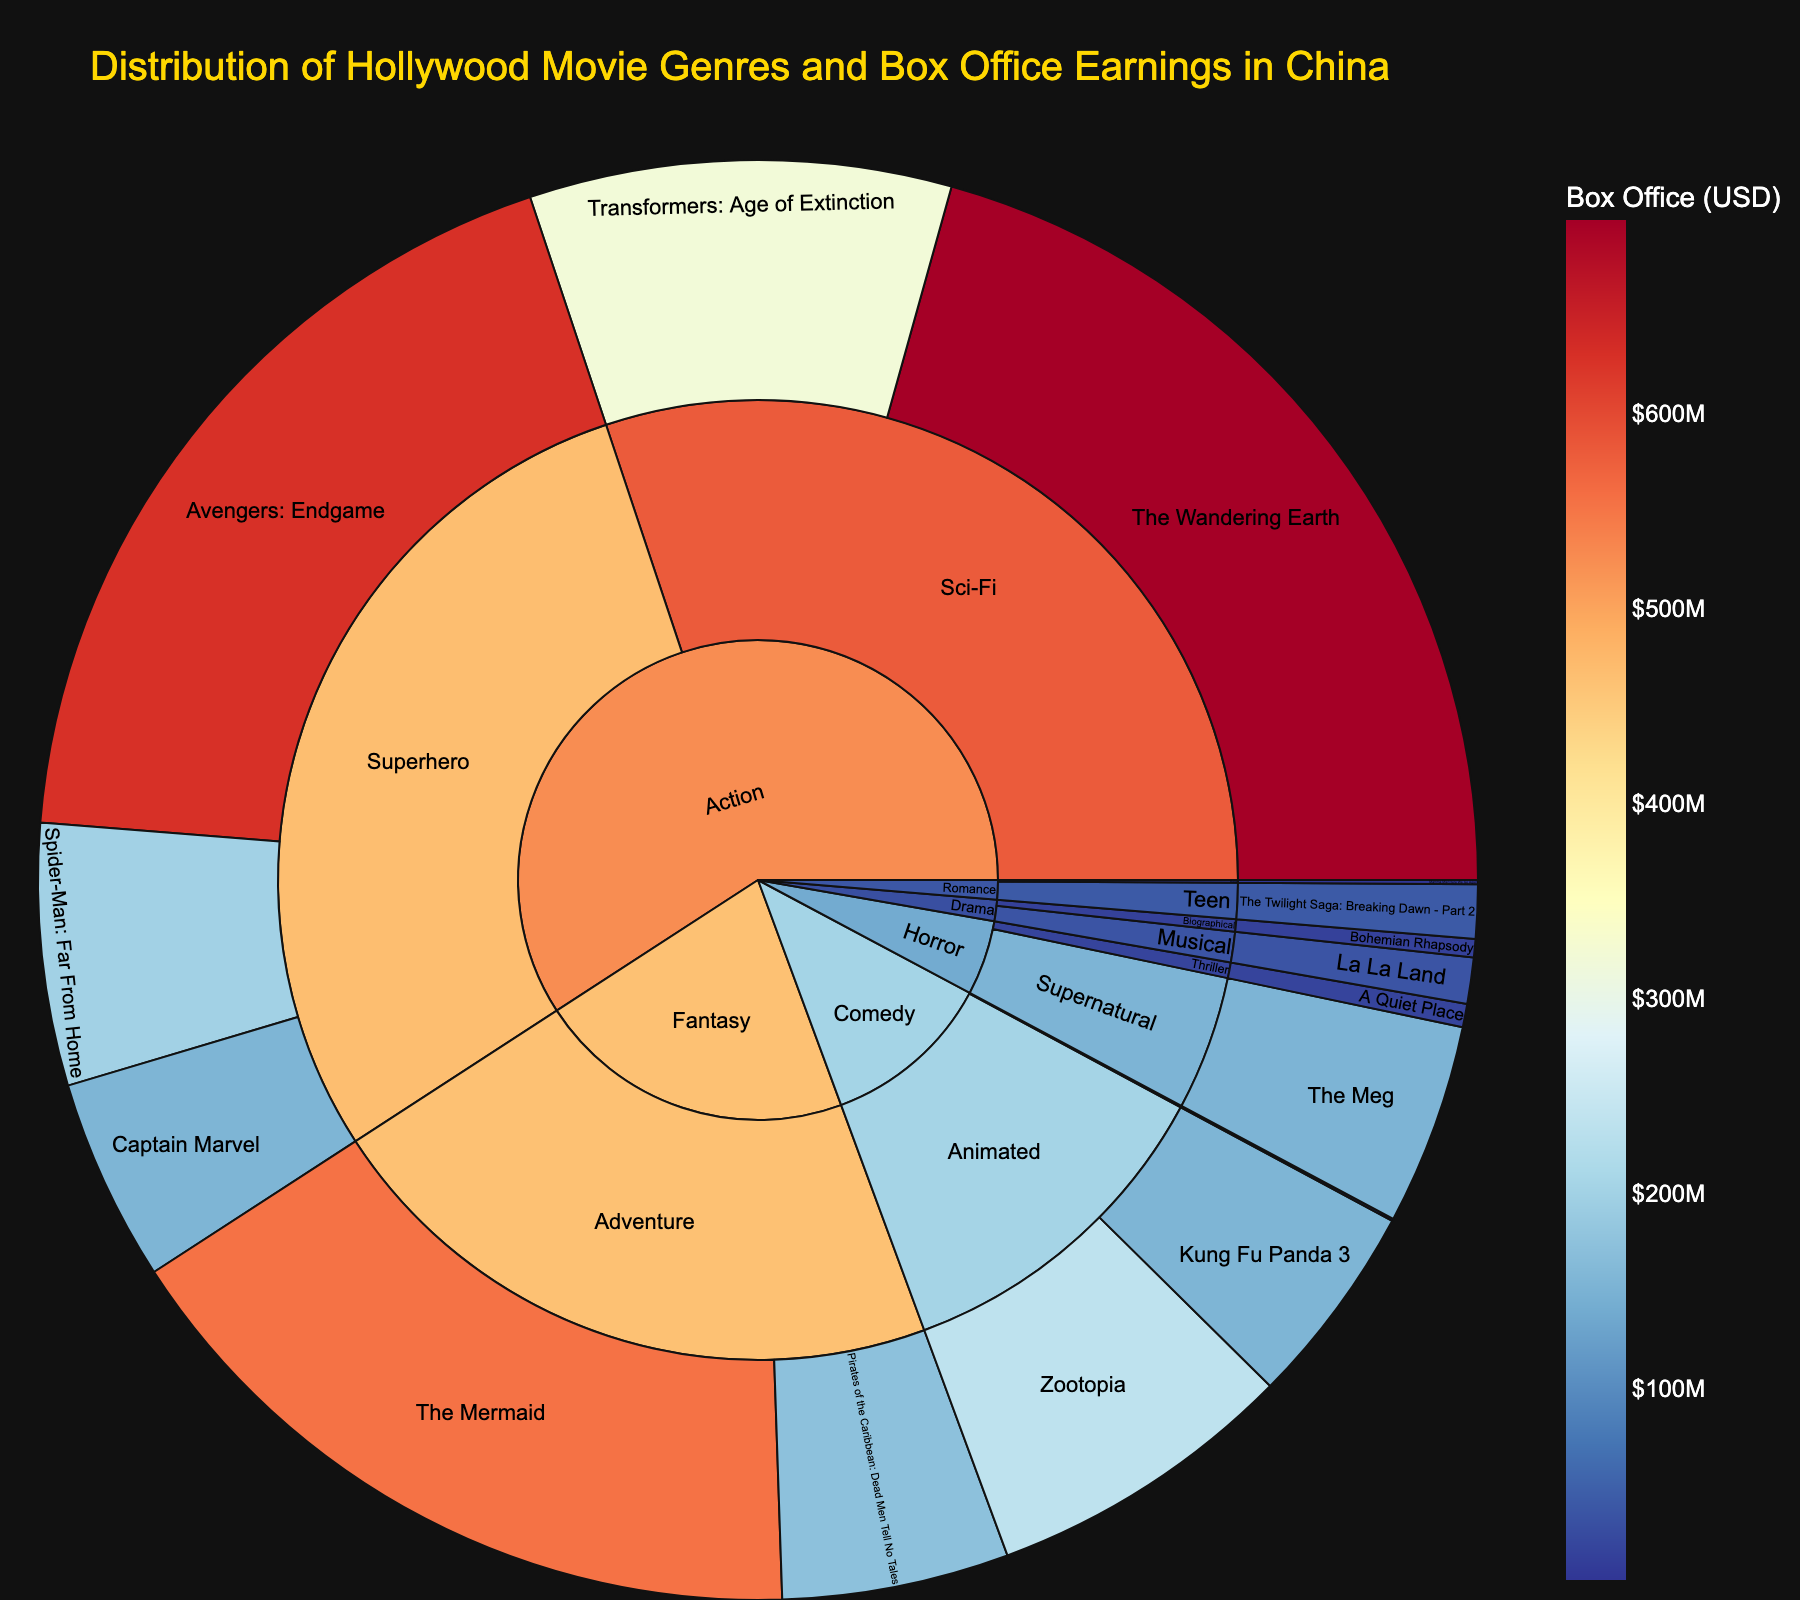What's the genre with the highest box office earnings? Look at the outer ring of the sunburst plot and sum the box office earnings for each genre. The 'Action' genre has multiple high-grossing movies like "Avengers: Endgame" and "The Wandering Earth," making it the highest.
Answer: Action Which movie has the highest box office earnings in China? Examine the smallest segments of the sunburst plot, which represent individual movies. "The Wandering Earth" stands out with the highest earnings at $699,000,000.
Answer: The Wandering Earth How does the box office earnings of "Avengers: Endgame" compare to "The Wandering Earth"? Identify the segments for both movies. "Avengers: Endgame" earned $629,000,000, while "The Wandering Earth" earned $699,000,000. Comparing these, "The Wandering Earth" earned more.
Answer: The Wandering Earth earned more What's the total box office earnings for Superhero subgenre movies? Add the box office earnings of "Avengers: Endgame" ($629,000,000), "Spider-Man: Far From Home" ($199,000,000), and "Captain Marvel" ($154,000,000). The total is $629,000,000 + $199,000,000 + $154,000,000 = $982,000,000.
Answer: $982,000,000 What are the top 3 movies by box office earnings in China? Look at the smallest segments representing individual movies and identify the top 3. "The Wandering Earth" ($699,000,000), "Avengers: Endgame" ($629,000,000), and "The Mermaid" ($553,800,000) are the top 3 movies.
Answer: The Wandering Earth, Avengers: Endgame, The Mermaid What's the average box office earnings for movies in the Comedy genre? The Comedy genre includes "Crazy Rich Asians" ($1,700,000), "Zootopia" ($235,600,000), and "Kung Fu Panda 3" ($154,000,000). Sum these to get $1,700,000 + $235,600,000 + $154,000,000 = $391,300,000. Divide by 3 to get an average of $391,300,000 / 3 = $130,433,333.
Answer: $130,433,333 Which movie in the Horror genre earned the least at the box office? Look at the segments under the Horror genre. "A Quiet Place" with $17,700,000 has lower earnings compared to "The Meg" ($153,000,000).
Answer: A Quiet Place What's the median box office earnings of movies in the Drama genre? The Drama genre includes "Bohemian Rhapsody" ($14,000,000) and "La La Land" ($35,000,000). The median is the middle value, which in this case is halfway between $14,000,000 and $35,000,000. The median is ($14,000,000 + $35,000,000) / 2 = $24,500,000.
Answer: $24,500,000 Which subgenre in the Action genre earned the most at the box office? Compare the Sci-Fi and Superhero subgenres within Action. The "Sci-Fi" subgenre includes "Transformers: Age of Extinction" ($320,000,000) and "The Wandering Earth" ($699,000,000), totaling $1,019,000,000. The "Superhero" subgenre totals $982,000,000. The "Sci-Fi" subgenre earned more.
Answer: Sci-Fi 